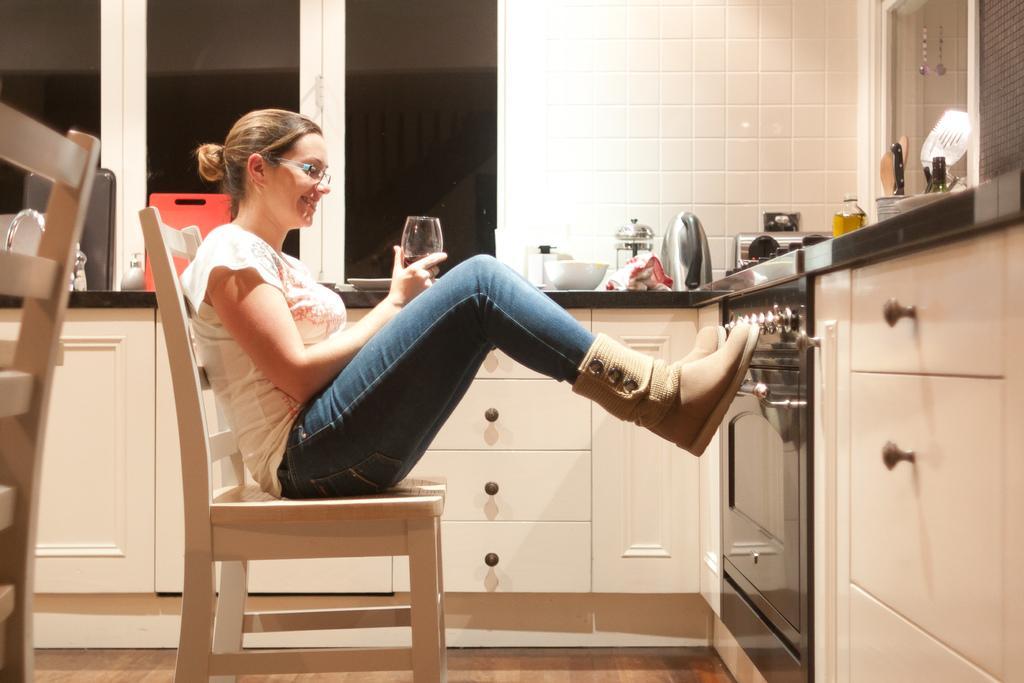In one or two sentences, can you explain what this image depicts? In this picture there is a woman sitting on the chair and is holding a glass. There is a bowl, knife ,spoon and other objects on the table. There is a microwave oven. There is a cupboard and a plate. 